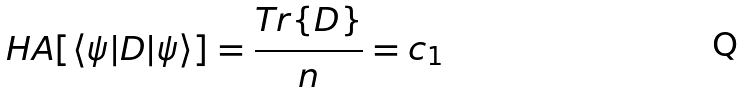Convert formula to latex. <formula><loc_0><loc_0><loc_500><loc_500>H A [ \langle \psi | D | \psi \rangle ] = \frac { T r \{ D \} } { n } = c _ { 1 }</formula> 